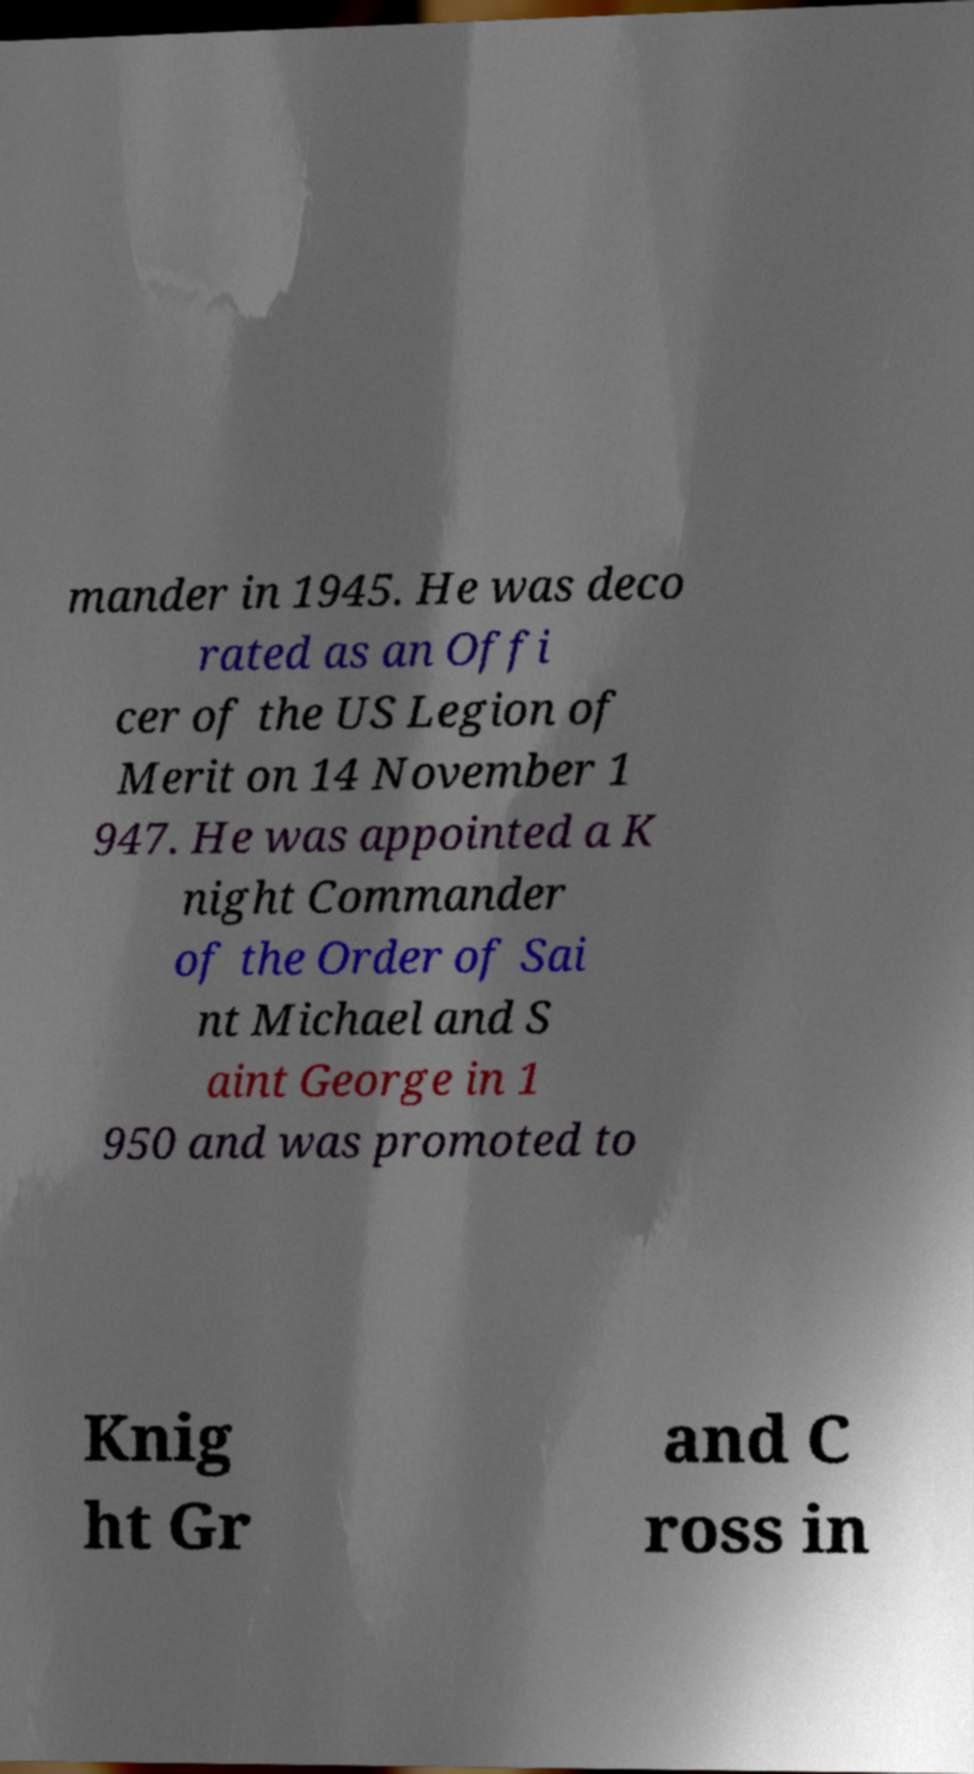There's text embedded in this image that I need extracted. Can you transcribe it verbatim? mander in 1945. He was deco rated as an Offi cer of the US Legion of Merit on 14 November 1 947. He was appointed a K night Commander of the Order of Sai nt Michael and S aint George in 1 950 and was promoted to Knig ht Gr and C ross in 